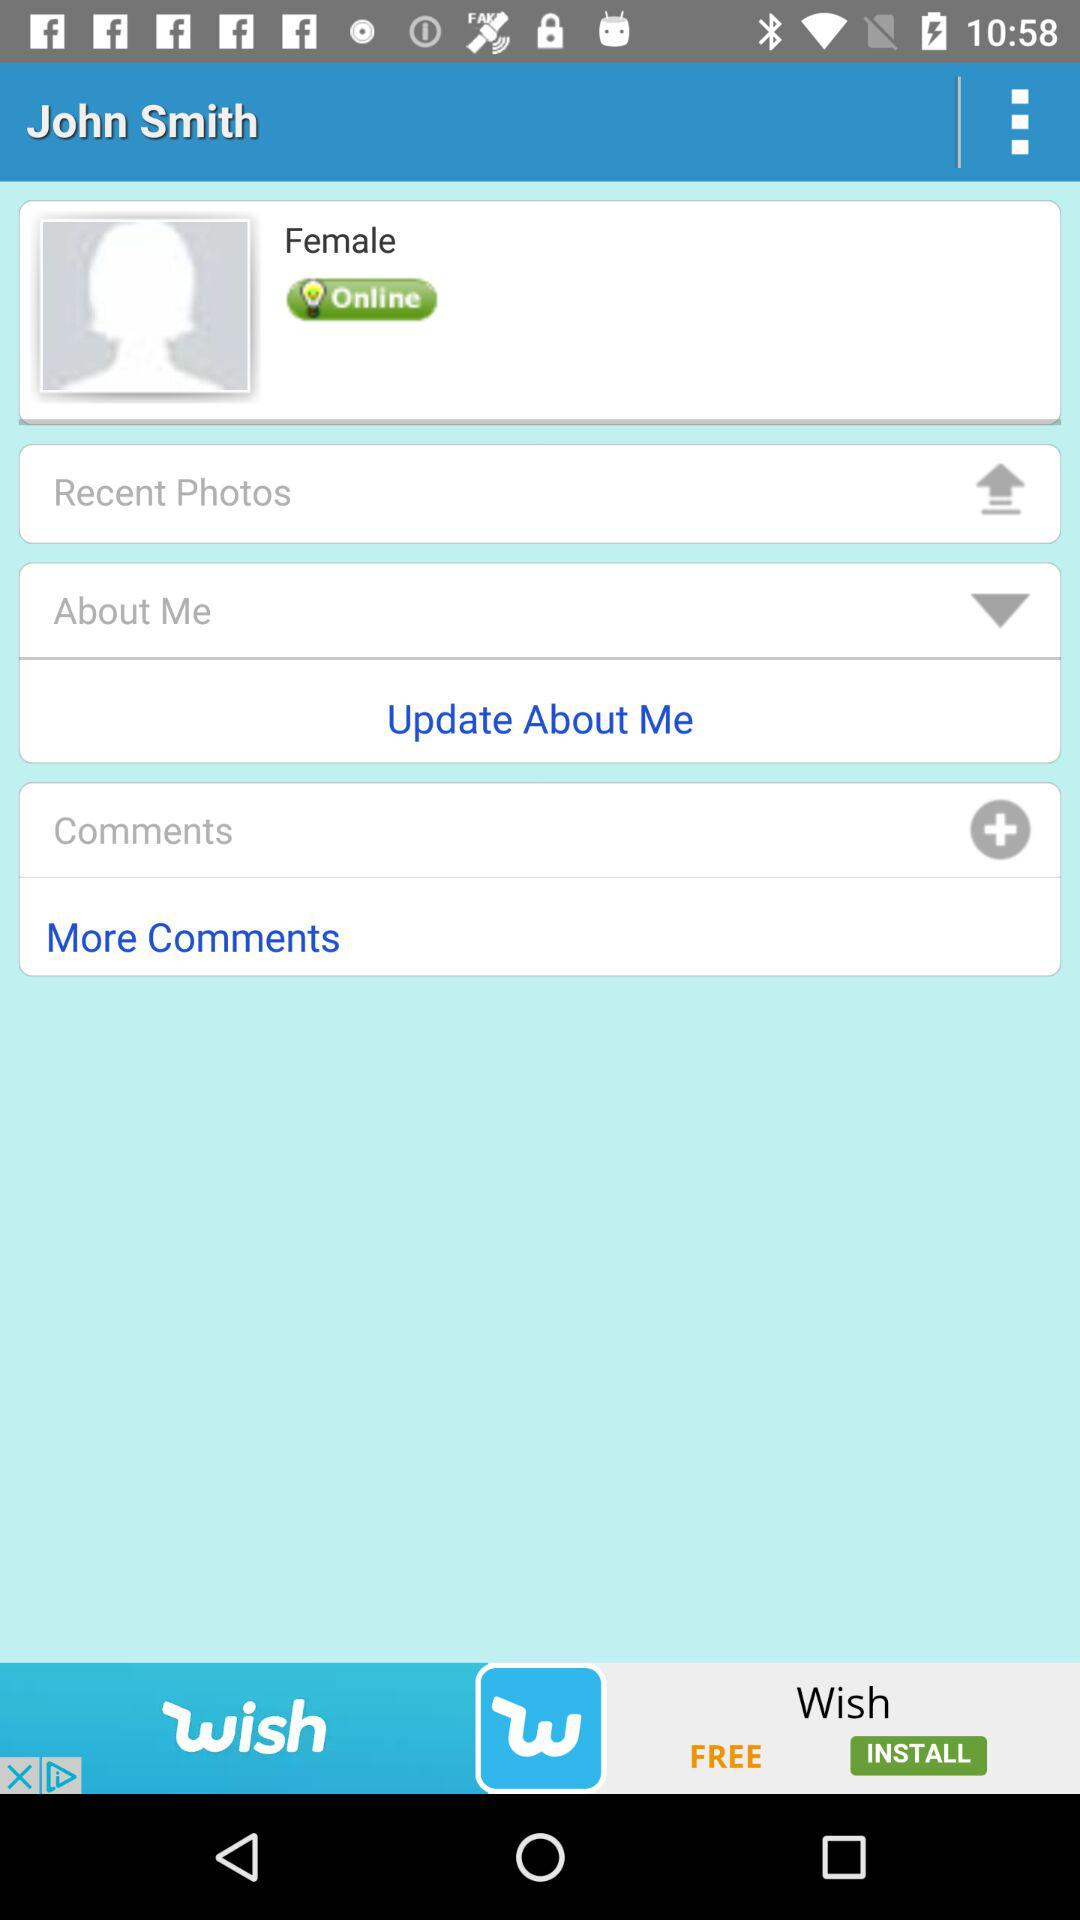What is the gender of the user? The gender of the user is female. 